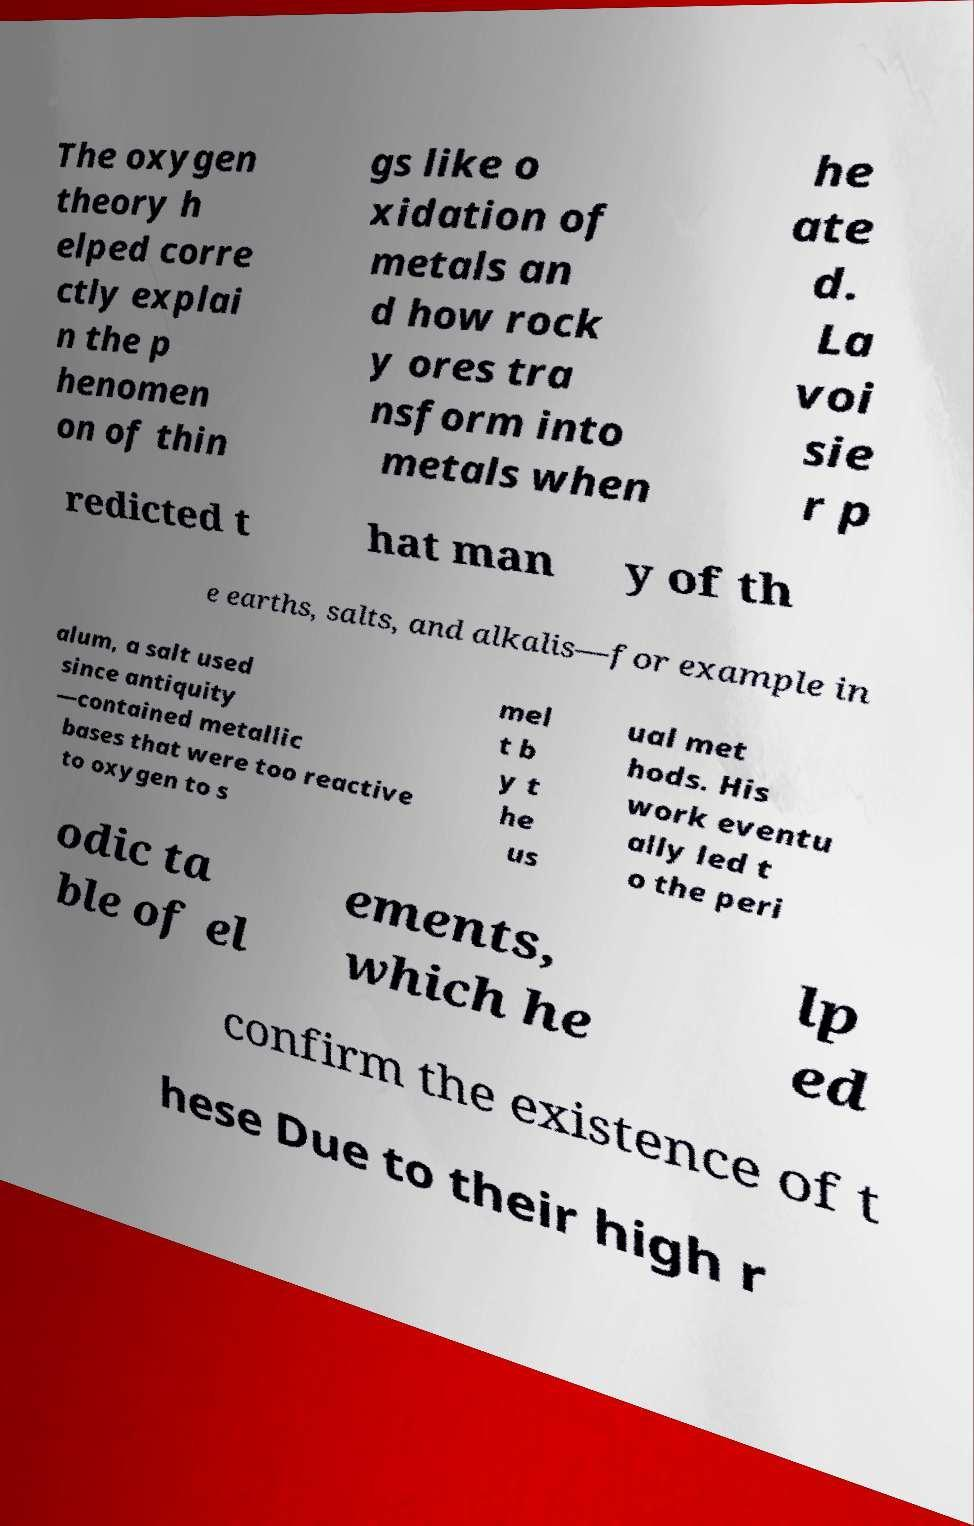There's text embedded in this image that I need extracted. Can you transcribe it verbatim? The oxygen theory h elped corre ctly explai n the p henomen on of thin gs like o xidation of metals an d how rock y ores tra nsform into metals when he ate d. La voi sie r p redicted t hat man y of th e earths, salts, and alkalis—for example in alum, a salt used since antiquity —contained metallic bases that were too reactive to oxygen to s mel t b y t he us ual met hods. His work eventu ally led t o the peri odic ta ble of el ements, which he lp ed confirm the existence of t hese Due to their high r 